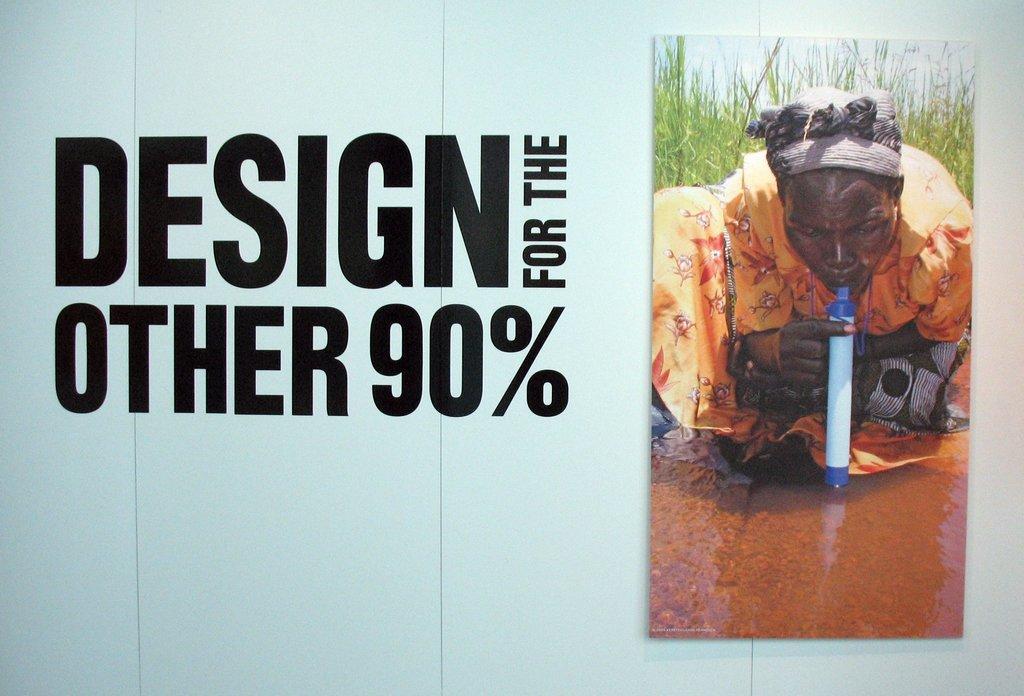Please provide a concise description of this image. In this image there is poster and a picture, in that picture a woman sitting on a floor and there is pipe in her mouth seeing into water, behind her there is grass, on the poster it is written as design for the other ninety percent. 